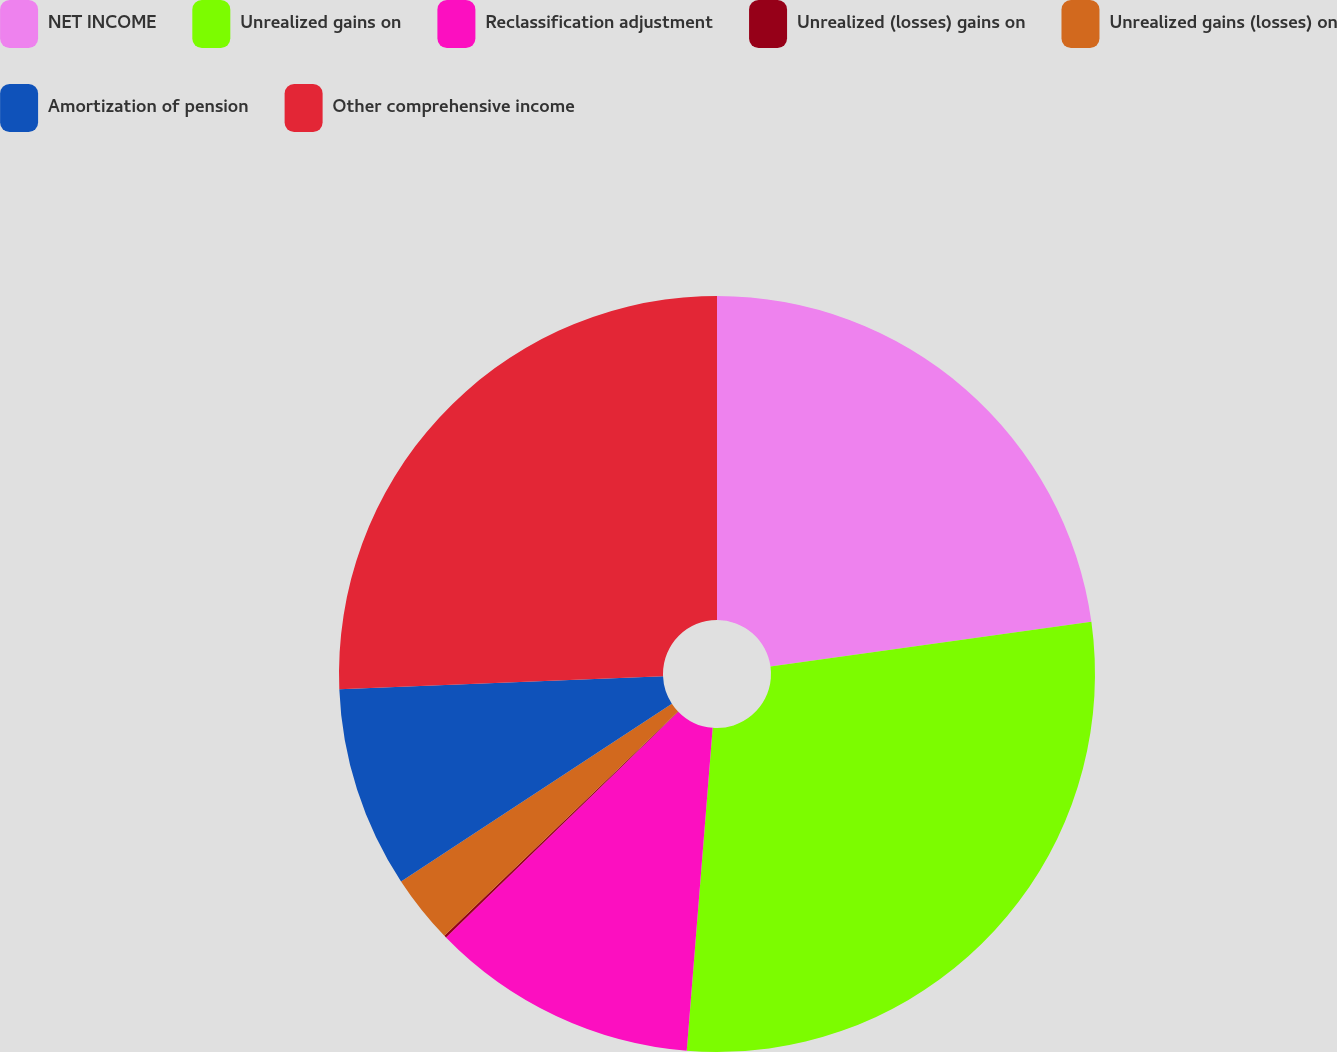Convert chart. <chart><loc_0><loc_0><loc_500><loc_500><pie_chart><fcel>NET INCOME<fcel>Unrealized gains on<fcel>Reclassification adjustment<fcel>Unrealized (losses) gains on<fcel>Unrealized gains (losses) on<fcel>Amortization of pension<fcel>Other comprehensive income<nl><fcel>22.8%<fcel>28.48%<fcel>11.45%<fcel>0.1%<fcel>2.93%<fcel>8.61%<fcel>25.64%<nl></chart> 